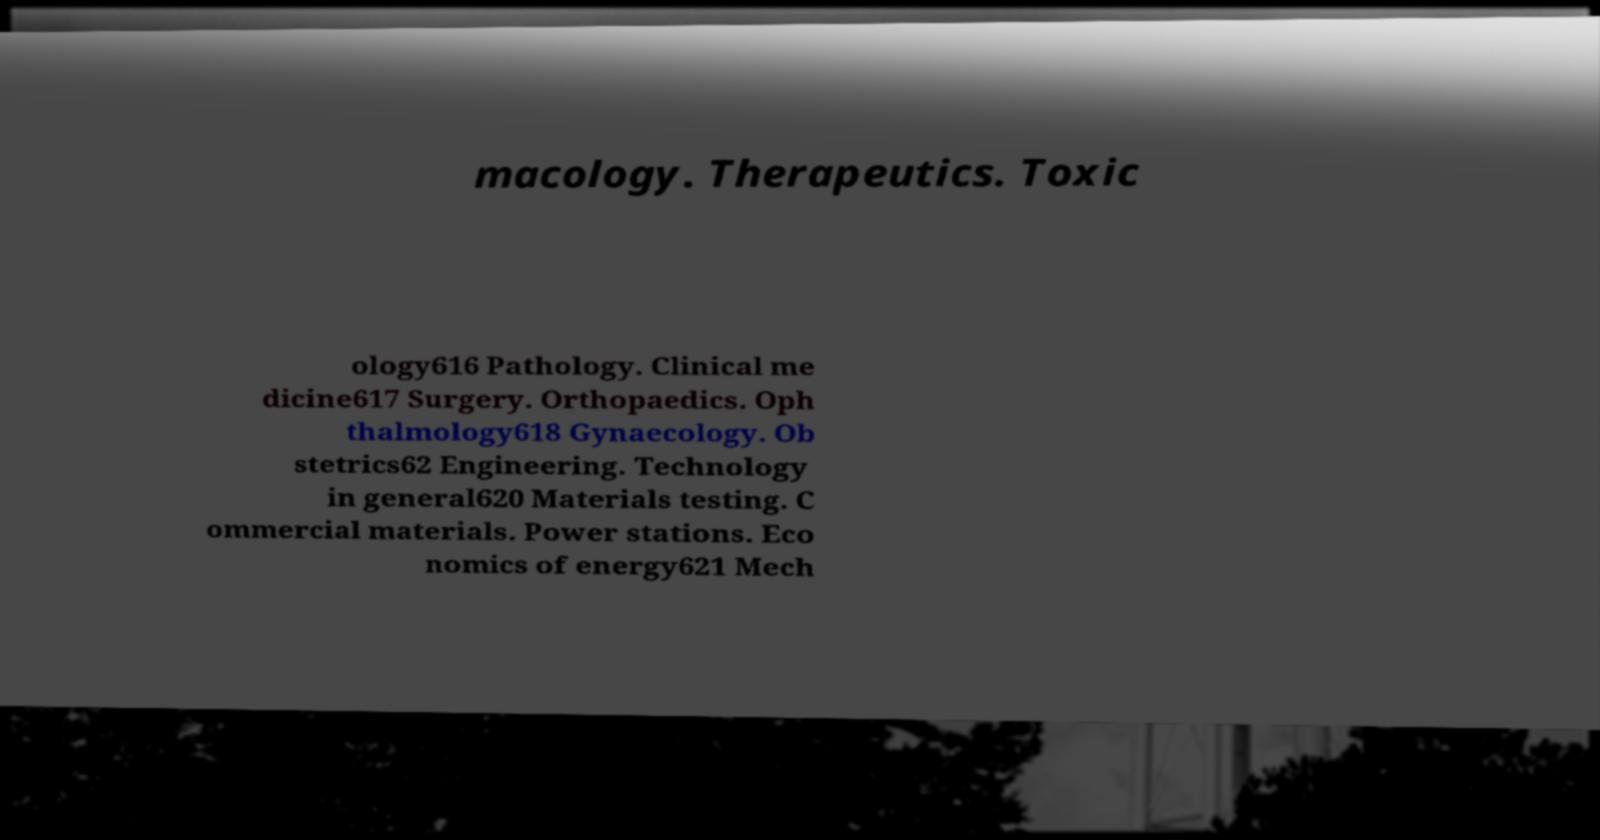There's text embedded in this image that I need extracted. Can you transcribe it verbatim? macology. Therapeutics. Toxic ology616 Pathology. Clinical me dicine617 Surgery. Orthopaedics. Oph thalmology618 Gynaecology. Ob stetrics62 Engineering. Technology in general620 Materials testing. C ommercial materials. Power stations. Eco nomics of energy621 Mech 